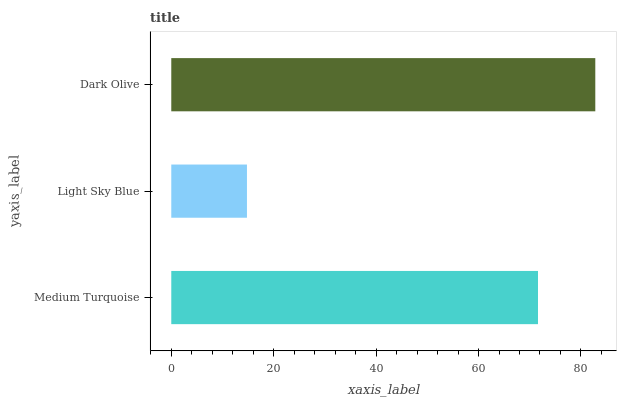Is Light Sky Blue the minimum?
Answer yes or no. Yes. Is Dark Olive the maximum?
Answer yes or no. Yes. Is Dark Olive the minimum?
Answer yes or no. No. Is Light Sky Blue the maximum?
Answer yes or no. No. Is Dark Olive greater than Light Sky Blue?
Answer yes or no. Yes. Is Light Sky Blue less than Dark Olive?
Answer yes or no. Yes. Is Light Sky Blue greater than Dark Olive?
Answer yes or no. No. Is Dark Olive less than Light Sky Blue?
Answer yes or no. No. Is Medium Turquoise the high median?
Answer yes or no. Yes. Is Medium Turquoise the low median?
Answer yes or no. Yes. Is Dark Olive the high median?
Answer yes or no. No. Is Light Sky Blue the low median?
Answer yes or no. No. 